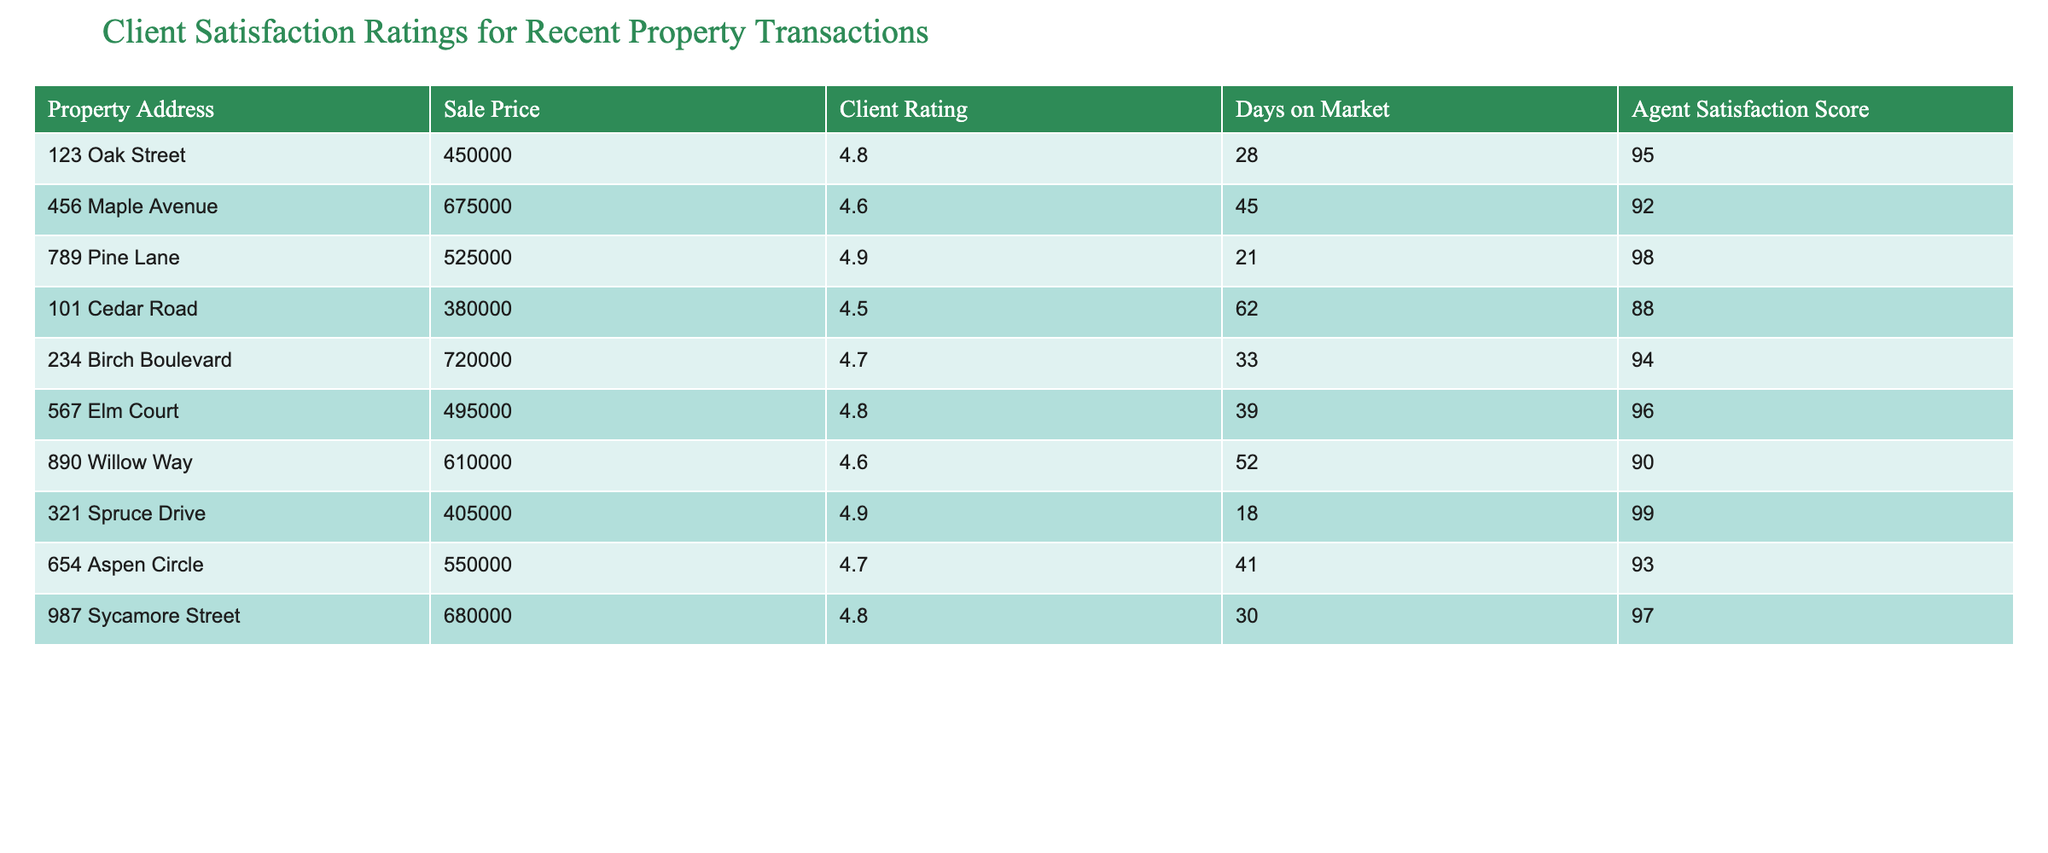What is the sale price of the property located at 123 Oak Street? The table lists the sale price directly next to the property address. For 123 Oak Street, the sale price is shown as 450000.
Answer: 450000 Which property has the highest client rating? To find this, I examine the "Client Rating" column and determine the highest value. The maximum rating is 4.9, which is associated with 789 Pine Lane and 321 Spruce Drive.
Answer: 789 Pine Lane and 321 Spruce Drive How many days on the market was the property at 890 Willow Way? The number of days on the market is stated in the table. For 890 Willow Way, it is indicated as 52 days.
Answer: 52 What is the average client rating for all properties listed? To calculate the average, I sum all client ratings (4.8 + 4.6 + 4.9 + 4.5 + 4.7 + 4.8 + 4.6 + 4.9 + 4.7 + 4.8) = 48.6. There are 10 properties, so the average is 48.6 / 10 = 4.86.
Answer: 4.86 True or False: The property on 101 Cedar Road has a client rating higher than 4.5. The table shows that 101 Cedar Road has a client rating of 4.5, which is not higher than 4.5. Therefore, the answer is False.
Answer: False What is the difference in days on market between the property with the lowest client rating and the property with the highest client rating? The property with the lowest rating (4.5) is 101 Cedar Road with 62 days on market, and the highest rating (4.9) properties are 789 Pine Lane and 321 Spruce Drive with 21 and 18 days respectively. The difference for the highest (21) is 62 - 21 = 41.
Answer: 41 Which agent had the highest satisfaction score, and what was that score? I examine the "Agent Satisfaction Score" column to find the maximum score. The highest score is 99, associated with 321 Spruce Drive.
Answer: 321 Spruce Drive, 99 What is the total sale price of all properties listed in the table? To find the total sale price, I sum all the sale prices: 450000 + 675000 + 525000 + 380000 + 720000 + 495000 + 610000 + 405000 + 550000 + 680000 = 4,270,000.
Answer: 4270000 How many properties have a client rating of at least 4.7? I count the entries in the "Client Rating" column that are 4.7 or higher: 4.8, 4.9, 4.7, 4.8, 4.9, 4.7, and 4.8 gives 7 properties.
Answer: 7 What is the average agent satisfaction score for properties that stayed on the market for more than 40 days? The properties with more than 40 days are 456 Maple Avenue (92), 890 Willow Way (90), 654 Aspen Circle (93), and 101 Cedar Road (88). Their average is (92 + 90 + 93 + 88) / 4 = 90.75.
Answer: 90.75 